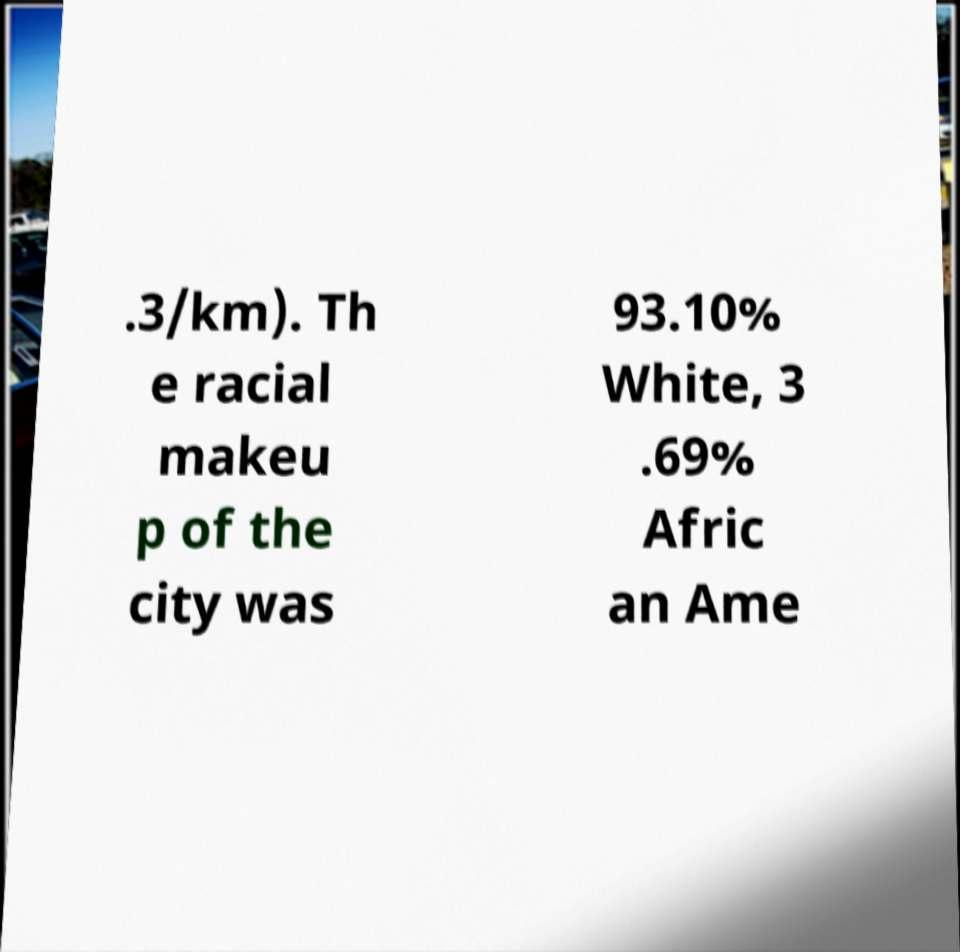Could you assist in decoding the text presented in this image and type it out clearly? .3/km). Th e racial makeu p of the city was 93.10% White, 3 .69% Afric an Ame 